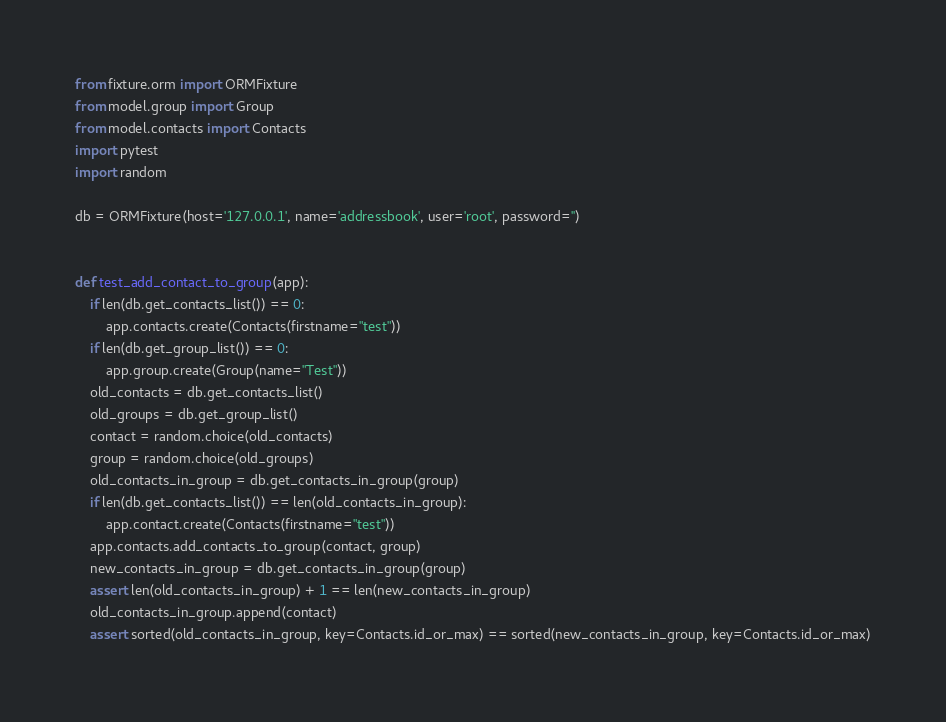<code> <loc_0><loc_0><loc_500><loc_500><_Python_>from fixture.orm import ORMFixture
from model.group import Group
from model.contacts import Contacts
import pytest
import random

db = ORMFixture(host='127.0.0.1', name='addressbook', user='root', password='')


def test_add_contact_to_group(app):
    if len(db.get_contacts_list()) == 0:
        app.contacts.create(Contacts(firstname="test"))
    if len(db.get_group_list()) == 0:
        app.group.create(Group(name="Test"))
    old_contacts = db.get_contacts_list()
    old_groups = db.get_group_list()
    contact = random.choice(old_contacts)
    group = random.choice(old_groups)
    old_contacts_in_group = db.get_contacts_in_group(group)
    if len(db.get_contacts_list()) == len(old_contacts_in_group):
        app.contact.create(Contacts(firstname="test"))
    app.contacts.add_contacts_to_group(contact, group)
    new_contacts_in_group = db.get_contacts_in_group(group)
    assert len(old_contacts_in_group) + 1 == len(new_contacts_in_group)
    old_contacts_in_group.append(contact)
    assert sorted(old_contacts_in_group, key=Contacts.id_or_max) == sorted(new_contacts_in_group, key=Contacts.id_or_max)







</code> 